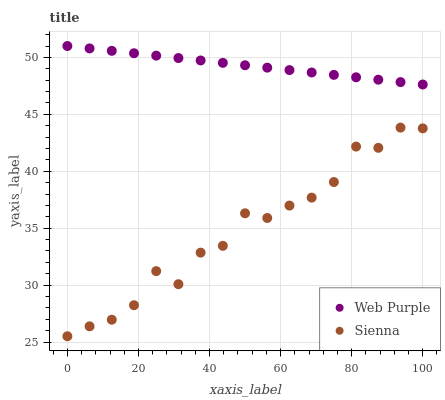Does Sienna have the minimum area under the curve?
Answer yes or no. Yes. Does Web Purple have the maximum area under the curve?
Answer yes or no. Yes. Does Web Purple have the minimum area under the curve?
Answer yes or no. No. Is Web Purple the smoothest?
Answer yes or no. Yes. Is Sienna the roughest?
Answer yes or no. Yes. Is Web Purple the roughest?
Answer yes or no. No. Does Sienna have the lowest value?
Answer yes or no. Yes. Does Web Purple have the lowest value?
Answer yes or no. No. Does Web Purple have the highest value?
Answer yes or no. Yes. Is Sienna less than Web Purple?
Answer yes or no. Yes. Is Web Purple greater than Sienna?
Answer yes or no. Yes. Does Sienna intersect Web Purple?
Answer yes or no. No. 